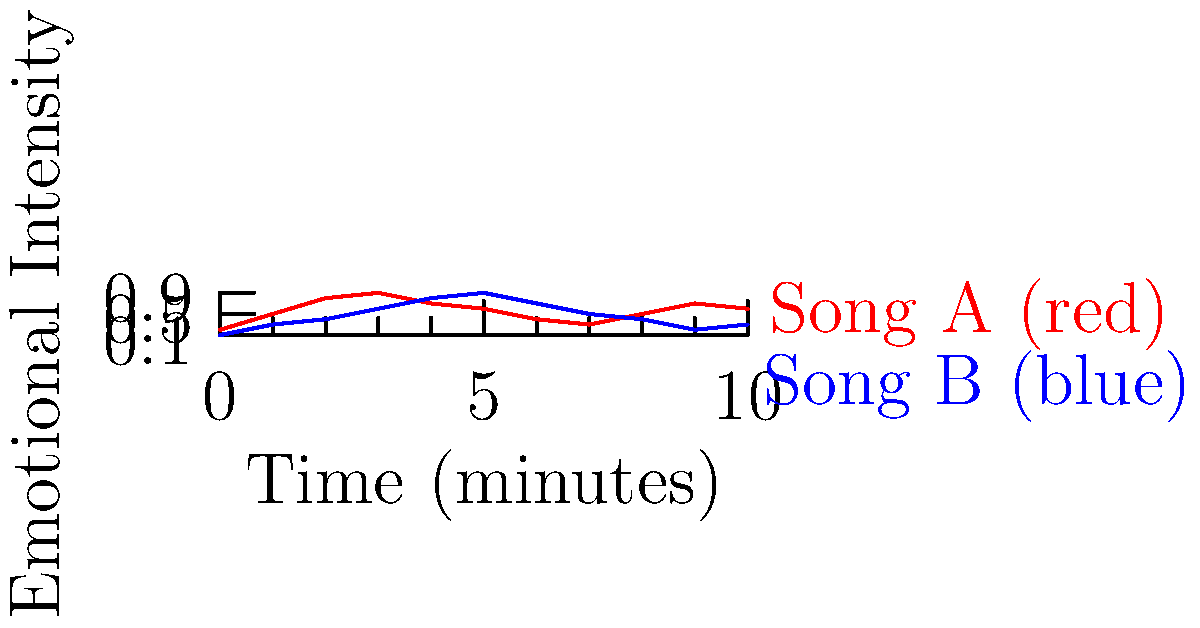As a podcast creator, you're analyzing two songs for potential inclusion in your next episode. The graph shows the emotional intensity of two songs over time, with red representing Song A and blue representing Song B. Which song would you choose to create a more dynamic listening experience for your audience? To determine which song would create a more dynamic listening experience, we need to analyze the emotional intensity variations for both songs:

1. Song A (red line):
   - Starts at a low intensity (0.2)
   - Quickly rises to a peak of 0.9 around the 3-minute mark
   - Experiences a gradual decline to 0.3 at the 7-minute mark
   - Ends with a slight increase to 0.6

2. Song B (blue line):
   - Begins at a very low intensity (0.1)
   - Steadily increases to a peak of 0.9 at the 6-minute mark
   - Experiences a sharp decline to 0.2 at the 9-minute mark
   - Ends with a slight increase to 0.3

3. Comparing the two songs:
   - Song A has more rapid changes in emotional intensity, especially in the first half
   - Song B has a more gradual build-up and a sharper decline near the end

4. For a dynamic listening experience:
   - Frequent changes in emotional intensity can keep listeners engaged
   - Song A offers more varied emotional content throughout its duration

Therefore, Song A would likely create a more dynamic listening experience for the podcast audience due to its more frequent and pronounced changes in emotional intensity.
Answer: Song A 